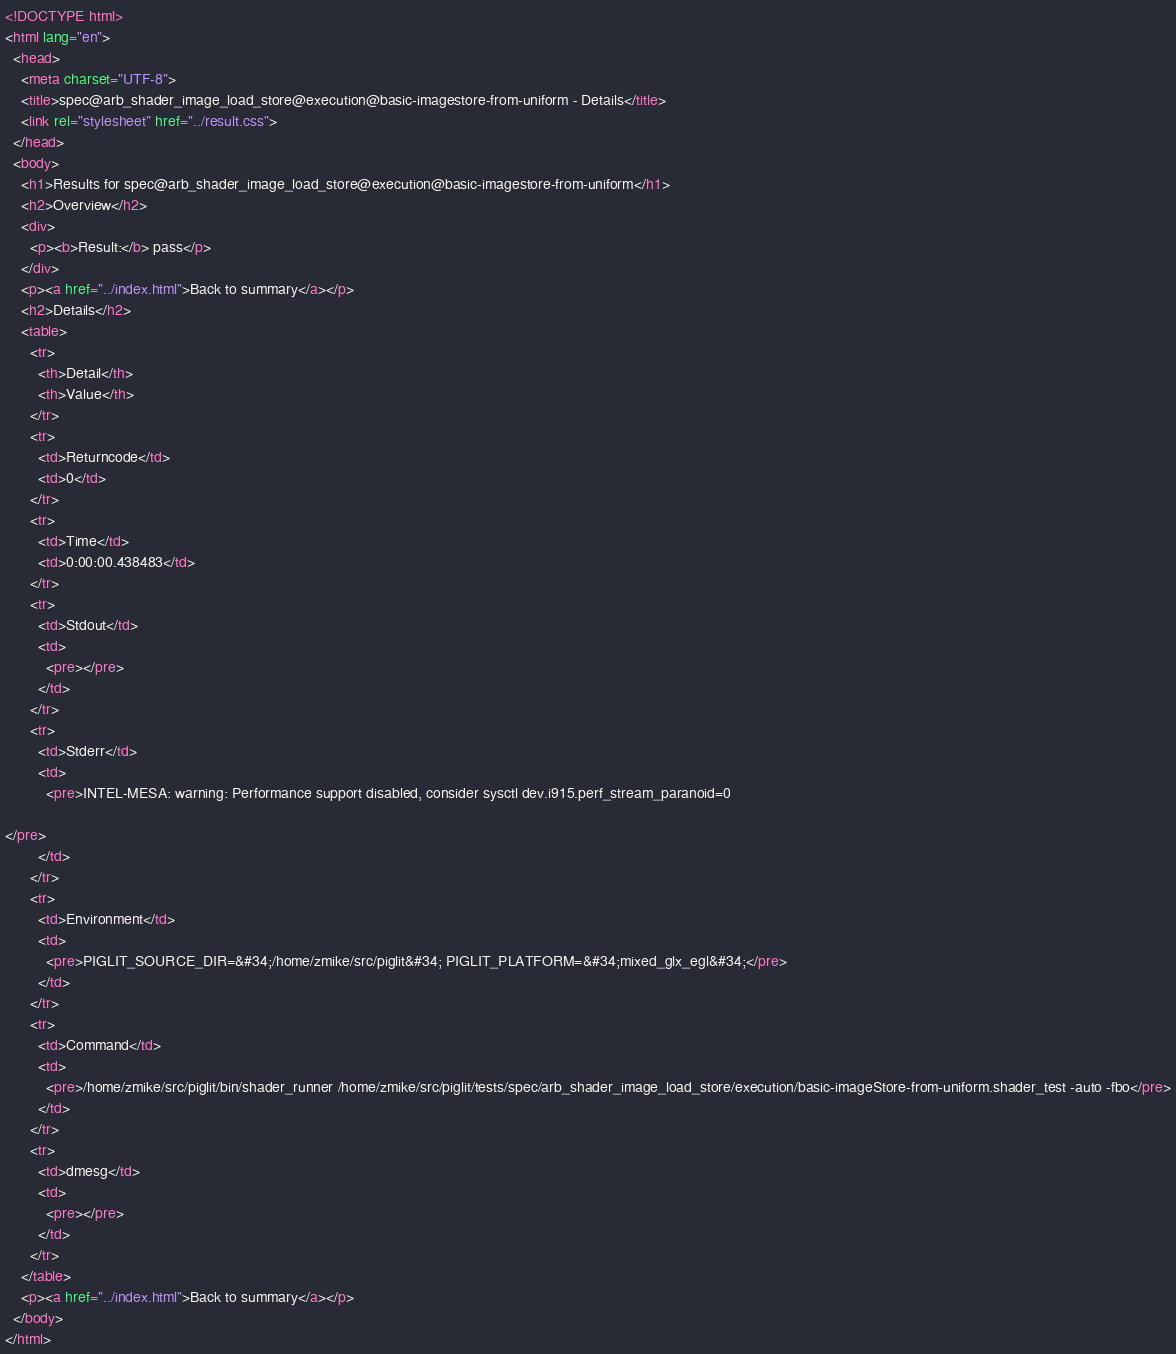<code> <loc_0><loc_0><loc_500><loc_500><_HTML_><!DOCTYPE html>
<html lang="en">
  <head>
    <meta charset="UTF-8">
    <title>spec@arb_shader_image_load_store@execution@basic-imagestore-from-uniform - Details</title>
    <link rel="stylesheet" href="../result.css">
  </head>
  <body>
    <h1>Results for spec@arb_shader_image_load_store@execution@basic-imagestore-from-uniform</h1>
    <h2>Overview</h2>
    <div>
      <p><b>Result:</b> pass</p>
    </div>
    <p><a href="../index.html">Back to summary</a></p>
    <h2>Details</h2>
    <table>
      <tr>
        <th>Detail</th>
        <th>Value</th>
      </tr>
      <tr>
        <td>Returncode</td>
        <td>0</td>
      </tr>
      <tr>
        <td>Time</td>
        <td>0:00:00.438483</td>
      </tr>
      <tr>
        <td>Stdout</td>
        <td>
          <pre></pre>
        </td>
      </tr>
      <tr>
        <td>Stderr</td>
        <td>
          <pre>INTEL-MESA: warning: Performance support disabled, consider sysctl dev.i915.perf_stream_paranoid=0

</pre>
        </td>
      </tr>
      <tr>
        <td>Environment</td>
        <td>
          <pre>PIGLIT_SOURCE_DIR=&#34;/home/zmike/src/piglit&#34; PIGLIT_PLATFORM=&#34;mixed_glx_egl&#34;</pre>
        </td>
      </tr>
      <tr>
        <td>Command</td>
        <td>
          <pre>/home/zmike/src/piglit/bin/shader_runner /home/zmike/src/piglit/tests/spec/arb_shader_image_load_store/execution/basic-imageStore-from-uniform.shader_test -auto -fbo</pre>
        </td>
      </tr>
      <tr>
        <td>dmesg</td>
        <td>
          <pre></pre>
        </td>
      </tr>
    </table>
    <p><a href="../index.html">Back to summary</a></p>
  </body>
</html>
</code> 